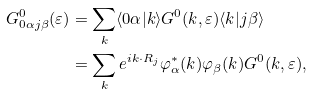<formula> <loc_0><loc_0><loc_500><loc_500>G ^ { 0 } _ { 0 \alpha j \beta } ( \varepsilon ) & = \sum _ { k } \langle 0 \alpha | k \rangle G ^ { 0 } ( k , \varepsilon ) \langle k | j \beta \rangle \\ & = \sum _ { k } e ^ { i k \cdot R _ { j } } \varphi ^ { * } _ { \alpha } ( k ) \varphi _ { \beta } ( k ) G ^ { 0 } ( k , \varepsilon ) ,</formula> 